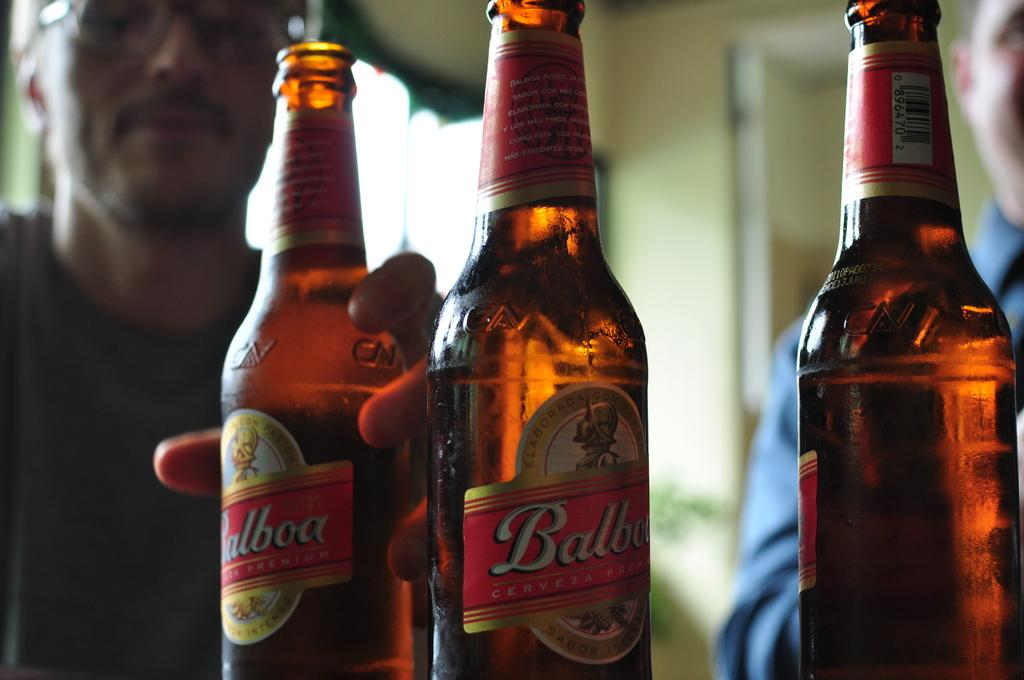<image>
Provide a brief description of the given image. Three bottles of Balboa beer are sitting in front of two men. 